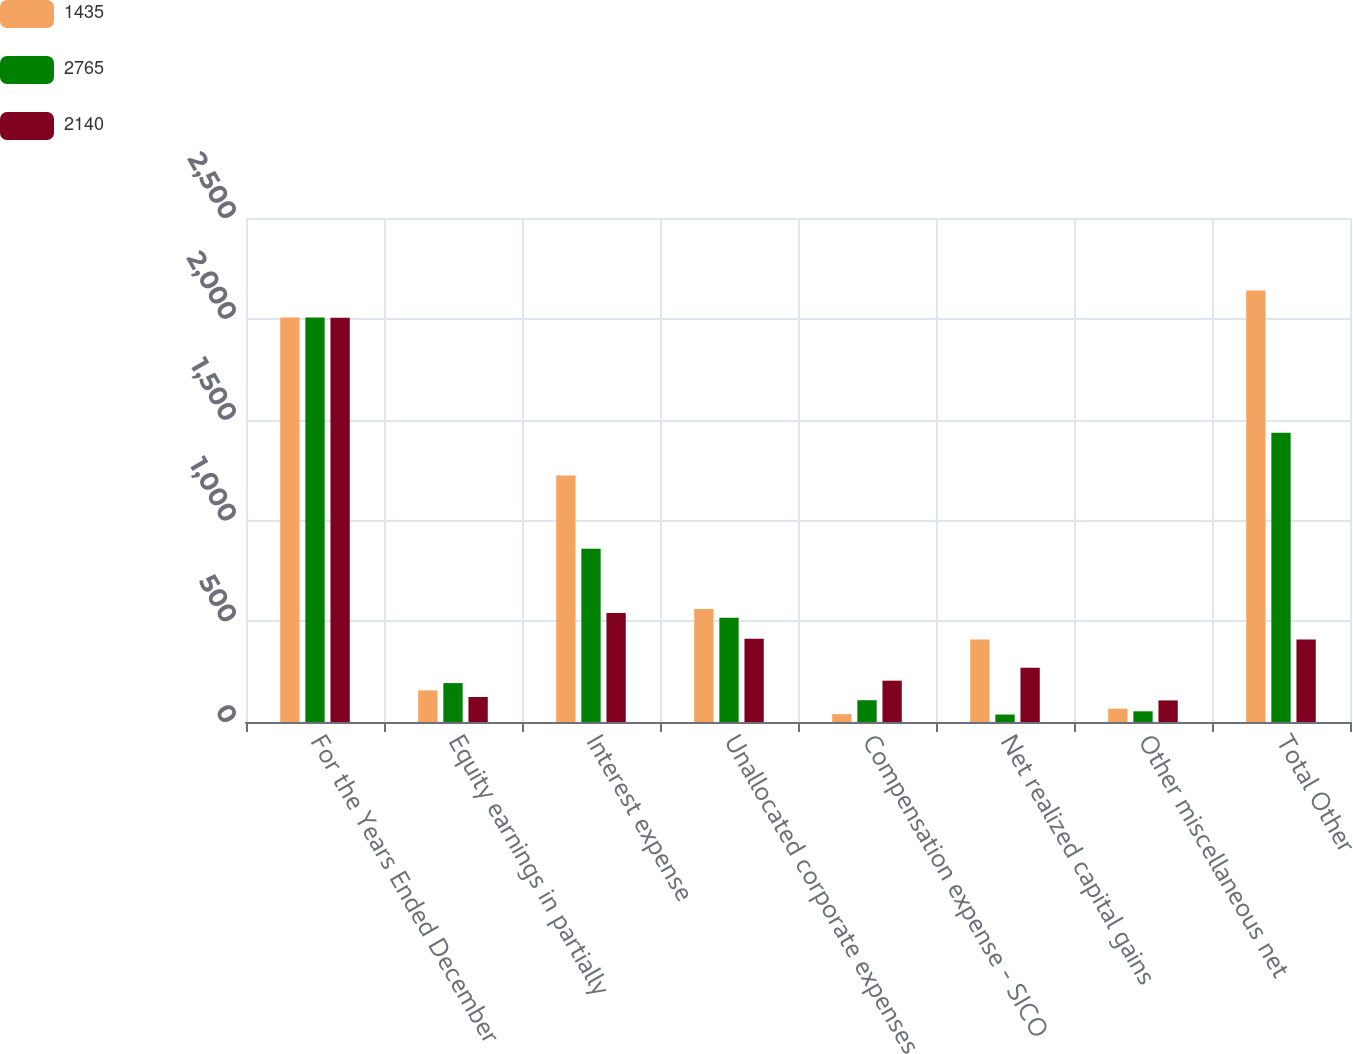Convert chart to OTSL. <chart><loc_0><loc_0><loc_500><loc_500><stacked_bar_chart><ecel><fcel>For the Years Ended December<fcel>Equity earnings in partially<fcel>Interest expense<fcel>Unallocated corporate expenses<fcel>Compensation expense - SICO<fcel>Net realized capital gains<fcel>Other miscellaneous net<fcel>Total Other<nl><fcel>1435<fcel>2007<fcel>157<fcel>1223<fcel>560<fcel>39<fcel>409<fcel>66<fcel>2140<nl><fcel>2765<fcel>2006<fcel>193<fcel>859<fcel>517<fcel>108<fcel>37<fcel>53<fcel>1435<nl><fcel>2140<fcel>2005<fcel>124<fcel>541<fcel>413<fcel>205<fcel>269<fcel>107<fcel>409<nl></chart> 